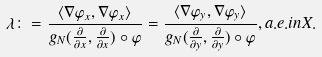<formula> <loc_0><loc_0><loc_500><loc_500>\lambda \colon = \frac { \langle \nabla \varphi _ { x } , \nabla \varphi _ { x } \rangle } { g _ { N } ( \frac { \partial } { \partial x } , \frac { \partial } { \partial x } ) \circ \varphi } = \frac { \langle \nabla \varphi _ { y } , \nabla \varphi _ { y } \rangle } { g _ { N } ( \frac { \partial } { \partial y } , \frac { \partial } { \partial y } ) \circ \varphi } , a . e . i n X .</formula> 